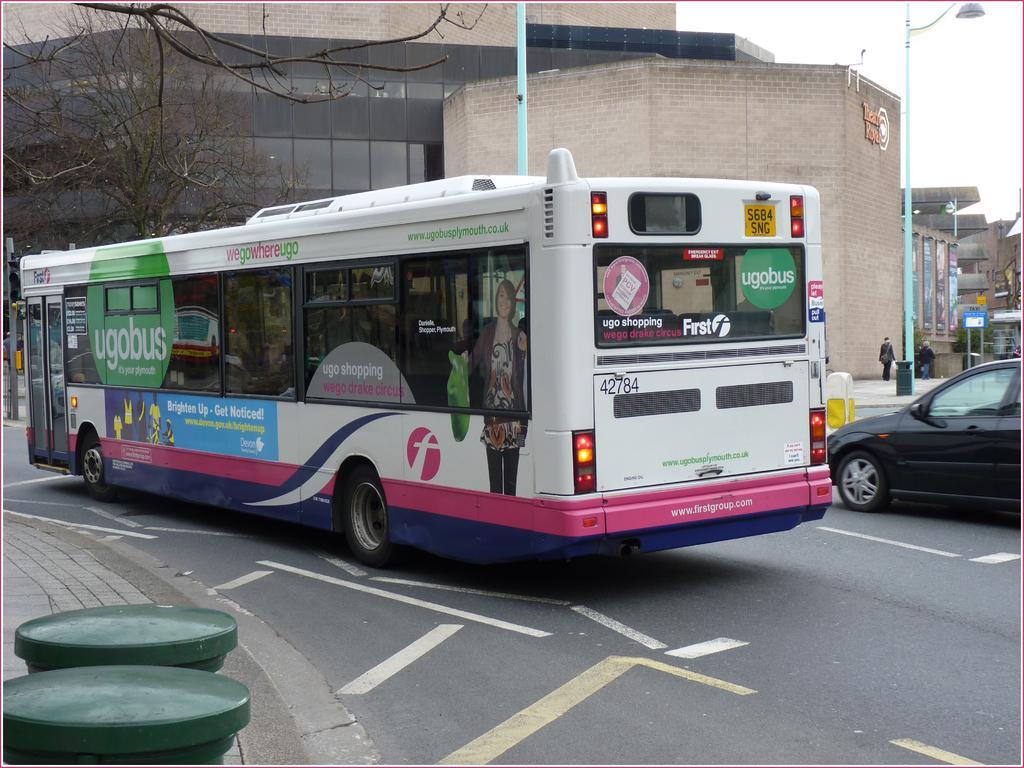Could you give a brief overview of what you see in this image? In this image we can see some buildings, some text with logo on the wall, some objects attached to the walls, some boards with poles, three people walking, some poles, one pillar on the road, some banners with text attached to the wall, two green color poles near to the road, one light with pole, some trees, one car, one bus on the road, some text with images on the bus, one dustbin near to the pole, at the top there is the sky, one man wearing a bag and holding a white color cover. 